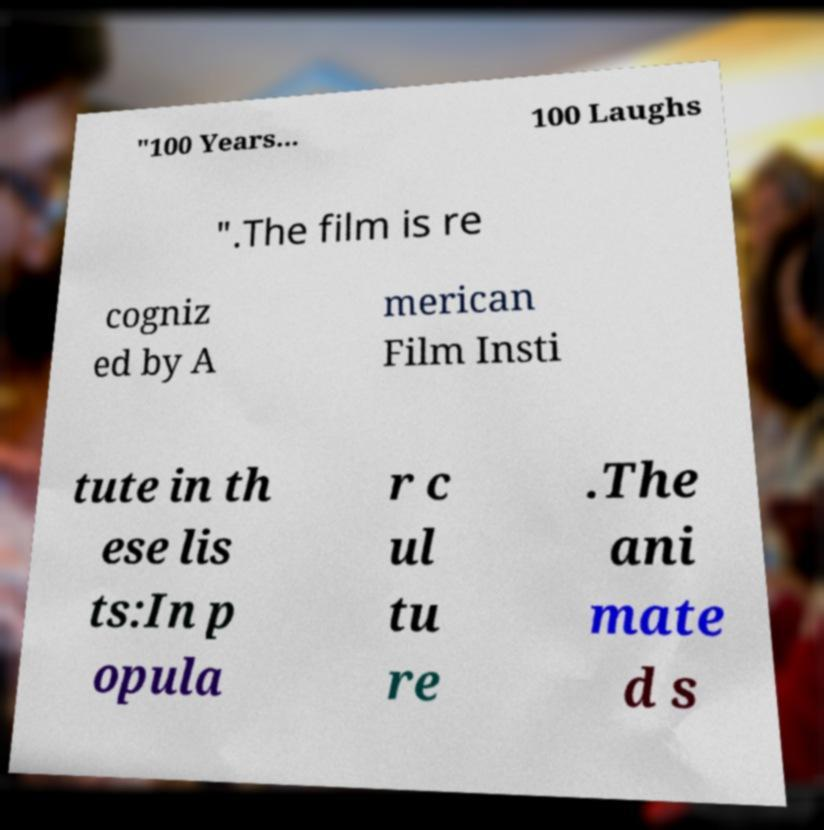Can you read and provide the text displayed in the image?This photo seems to have some interesting text. Can you extract and type it out for me? "100 Years... 100 Laughs ".The film is re cogniz ed by A merican Film Insti tute in th ese lis ts:In p opula r c ul tu re .The ani mate d s 